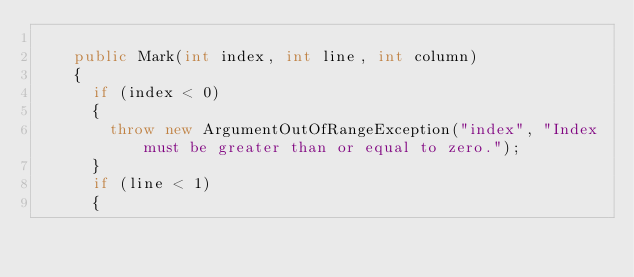<code> <loc_0><loc_0><loc_500><loc_500><_C#_>
		public Mark(int index, int line, int column)
		{
			if (index < 0)
			{
				throw new ArgumentOutOfRangeException("index", "Index must be greater than or equal to zero.");
			}
			if (line < 1)
			{</code> 